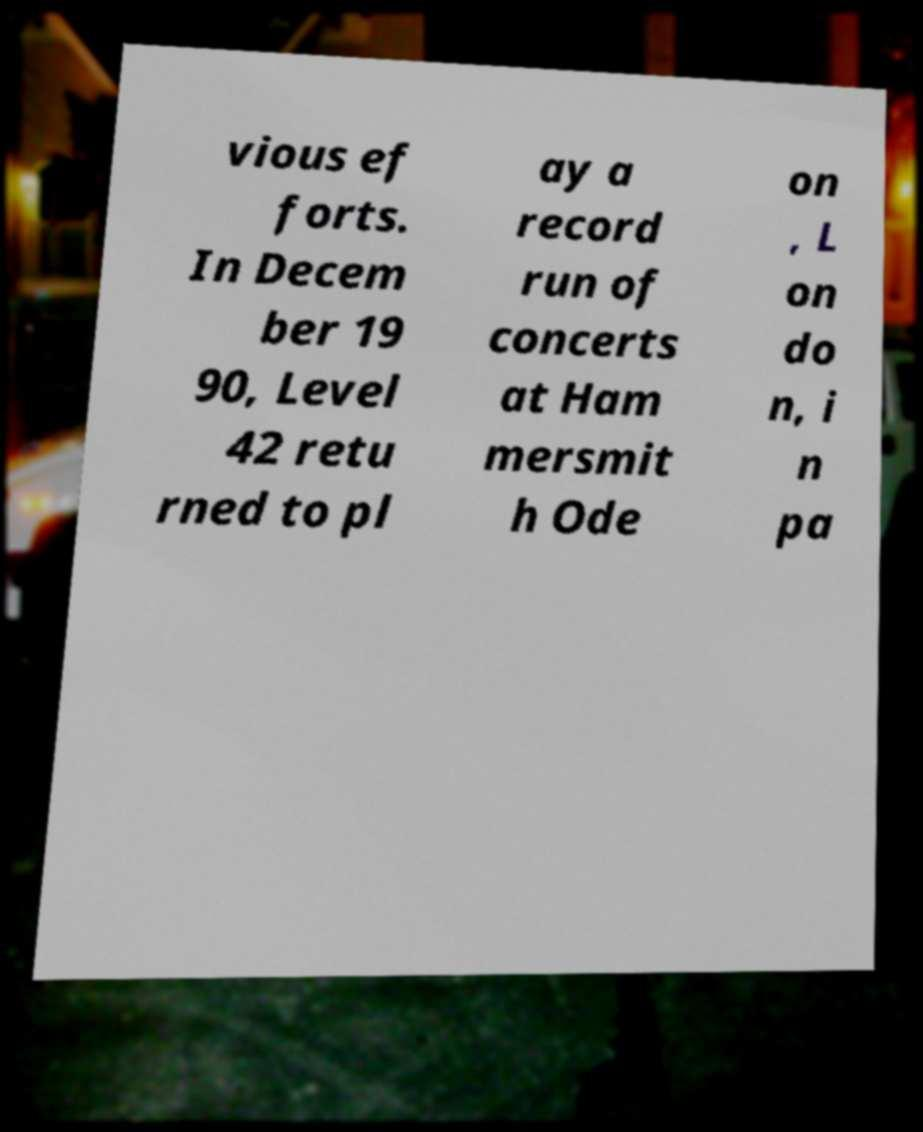Could you extract and type out the text from this image? vious ef forts. In Decem ber 19 90, Level 42 retu rned to pl ay a record run of concerts at Ham mersmit h Ode on , L on do n, i n pa 